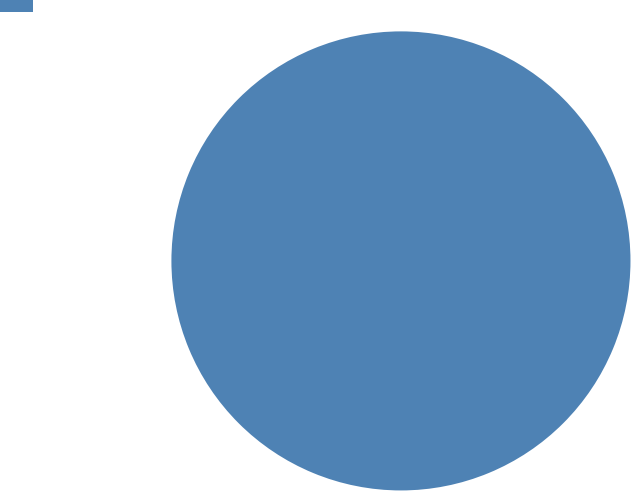<chart> <loc_0><loc_0><loc_500><loc_500><pie_chart><ecel><nl><fcel>100.0%<nl></chart> 